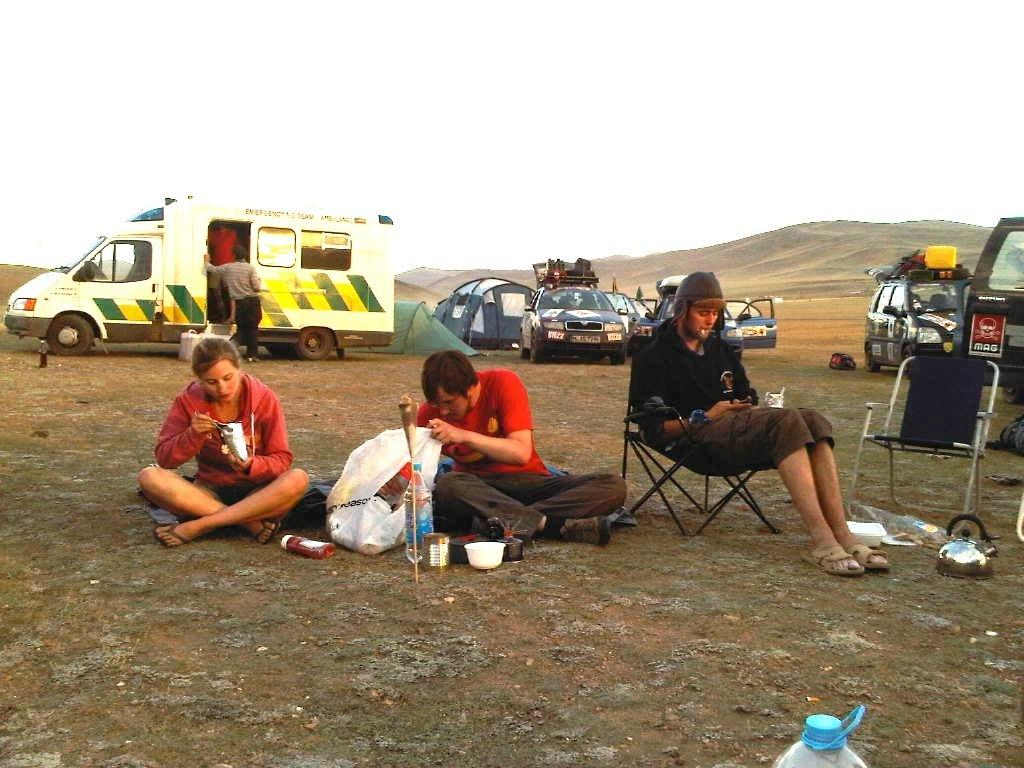Can you describe this image briefly? In this image we can see people sitting. There is a cover and bottles placed on the ground. There are chairs. In the background we can see vehicles. There are hills and sky. We can see a bowl. On the left there is a man. 